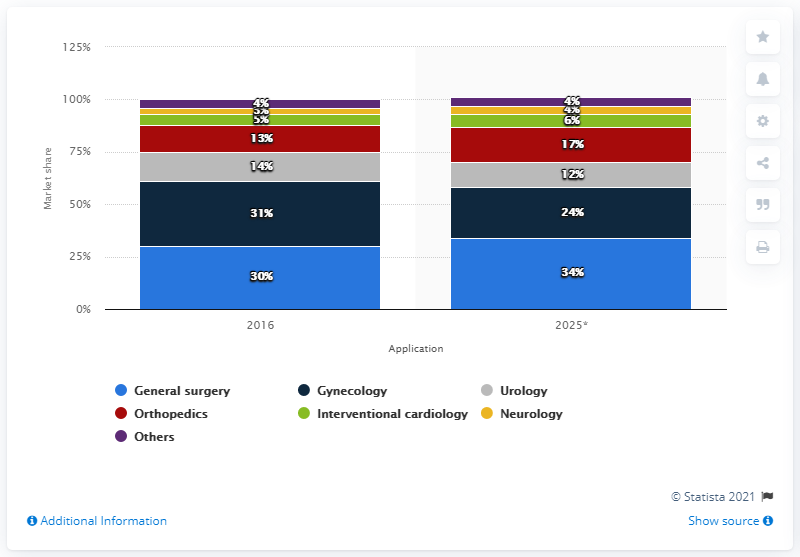Mention a couple of crucial points in this snapshot. The global market for surgical robots by application share was in 2016. 